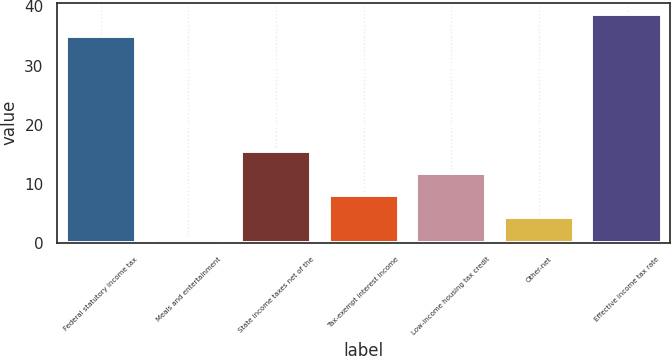<chart> <loc_0><loc_0><loc_500><loc_500><bar_chart><fcel>Federal statutory income tax<fcel>Meals and entertainment<fcel>State income taxes net of the<fcel>Tax-exempt interest income<fcel>Low-income housing tax credit<fcel>Other-net<fcel>Effective income tax rate<nl><fcel>35<fcel>0.7<fcel>15.54<fcel>8.12<fcel>11.83<fcel>4.41<fcel>38.71<nl></chart> 